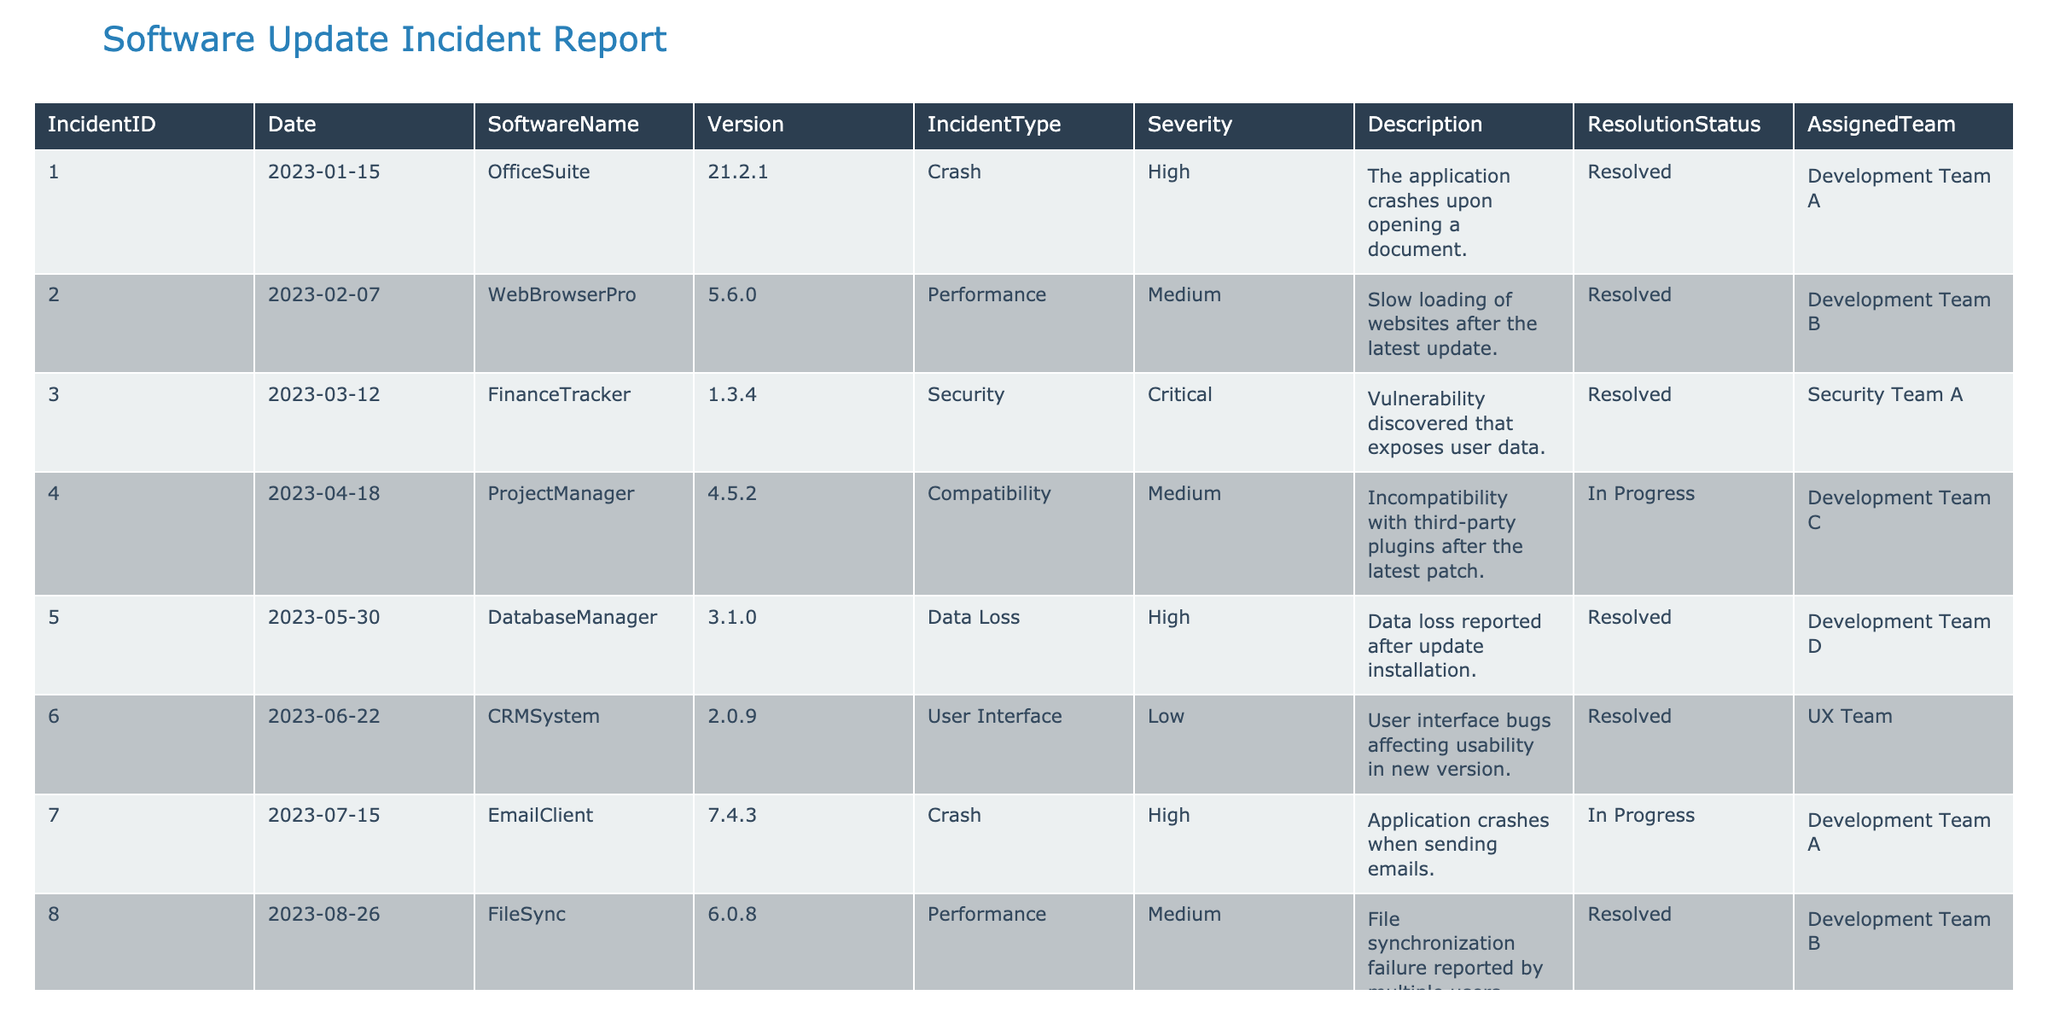What incident had the highest severity rating? The "Security" incident related to "FinanceTracker" (IncidentID 003) is classified as "Critical," which is the highest severity rating according to the table.
Answer: FinanceTracker How many incidents are still in progress? There are two incidents with a "Resolution Status" of "In Progress," which are IncidentIDs 004 and 007.
Answer: 2 What is the most common incident type recorded in the table? Upon reviewing the table, the "Crash" incident type appears twice (for OfficeSuite and EmailClient). "Performance" and "Compatibility" also appear twice, but "Crash" is the most frequent when considering unique types against frequency.
Answer: Crash Are there any incidents still unresolved? Based on the table, there are two incidents: IncidentID 004 (ProjectManager) and IncidentID 007 (EmailClient), both listed as "In Progress," which indicates they are unresolved.
Answer: Yes What is the average severity of incidents related to user interface issues? There is one user interface incident from the table (CRMSystem with IncidentID 006, Severity Low). The average severity based on manual ranking would be Low, which is a unique value so cannot be averaged.
Answer: Low How many different software names experienced data loss issues? Only one software, "DatabaseManager" (IncidentID 005), has a "Data Loss" incident recorded in the table.
Answer: 1 How many incidents reported were related to performance issues? There are two performance-related incidents: IncidentID 002 (WebBrowserPro) and IncidentID 008 (FileSync). Therefore, there were 2 incidents classified under performance.
Answer: 2 Which team was assigned the most incidents? Upon examining the assignments, Development Team A is assigned to two incidents (IncidentIDs 001 and 007), which is more than any other team. Therefore, this team handled the most incidents.
Answer: Development Team A Which incident was the most recent, and what was its type? IncidentID 010 (AccountingSoftware) is the most current incident as it occurred on 2023-10-05, and the type is "Compatibility."
Answer: Compatibility 